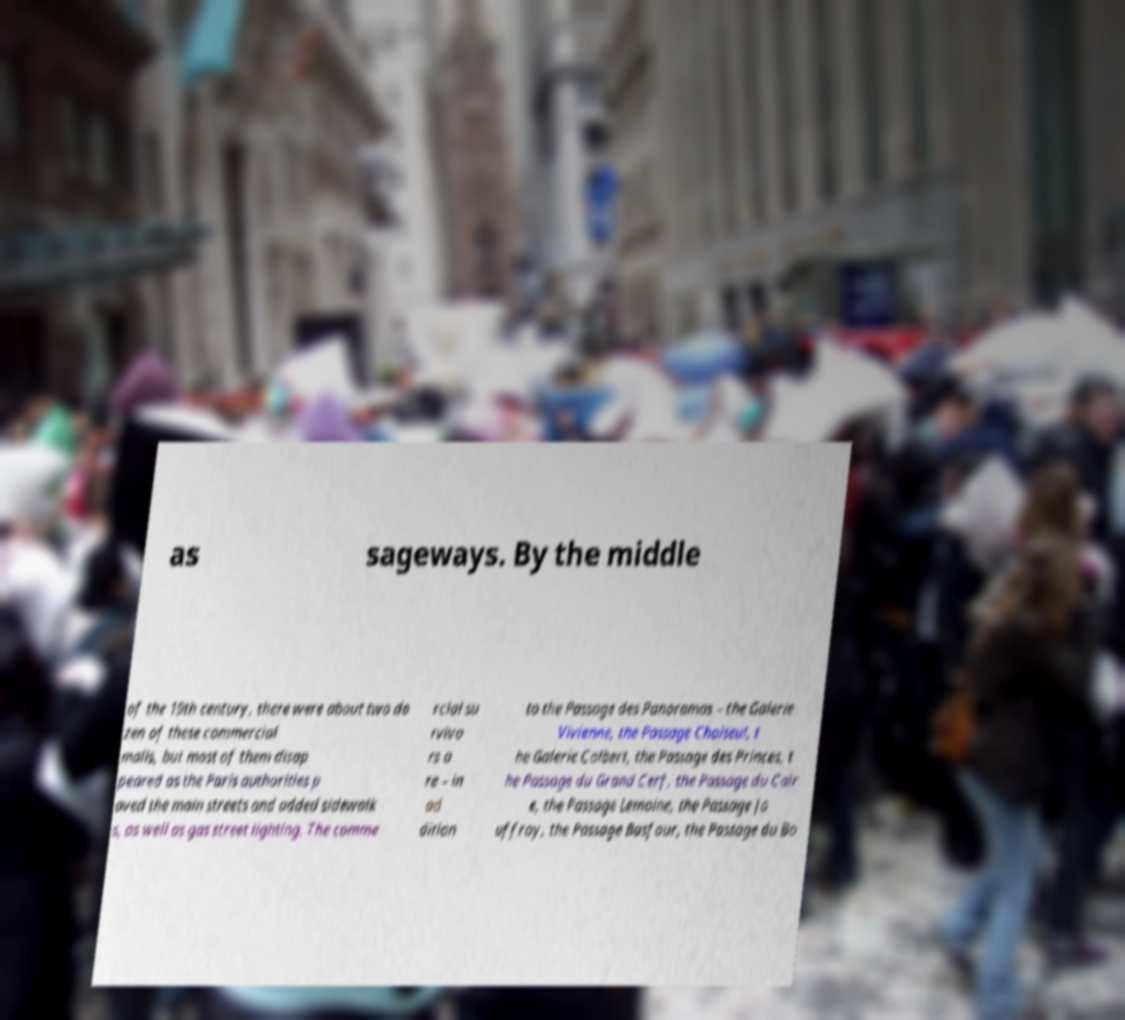Please identify and transcribe the text found in this image. as sageways. By the middle of the 19th century, there were about two do zen of these commercial malls, but most of them disap peared as the Paris authorities p aved the main streets and added sidewalk s, as well as gas street lighting. The comme rcial su rvivo rs a re – in ad dition to the Passage des Panoramas – the Galerie Vivienne, the Passage Choiseul, t he Galerie Colbert, the Passage des Princes, t he Passage du Grand Cerf, the Passage du Cair e, the Passage Lemoine, the Passage Jo uffroy, the Passage Basfour, the Passage du Bo 